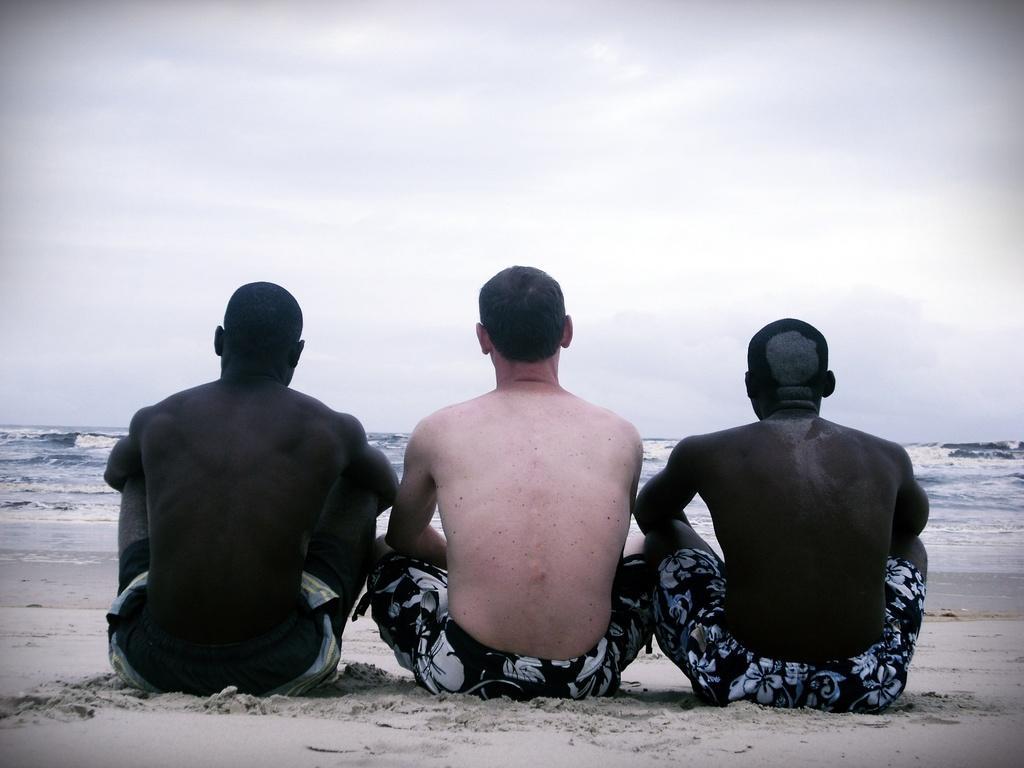In one or two sentences, can you explain what this image depicts? In this picture I can see there are three people sitting on the sand and there is an ocean in the backdrop, the sky is clear. 